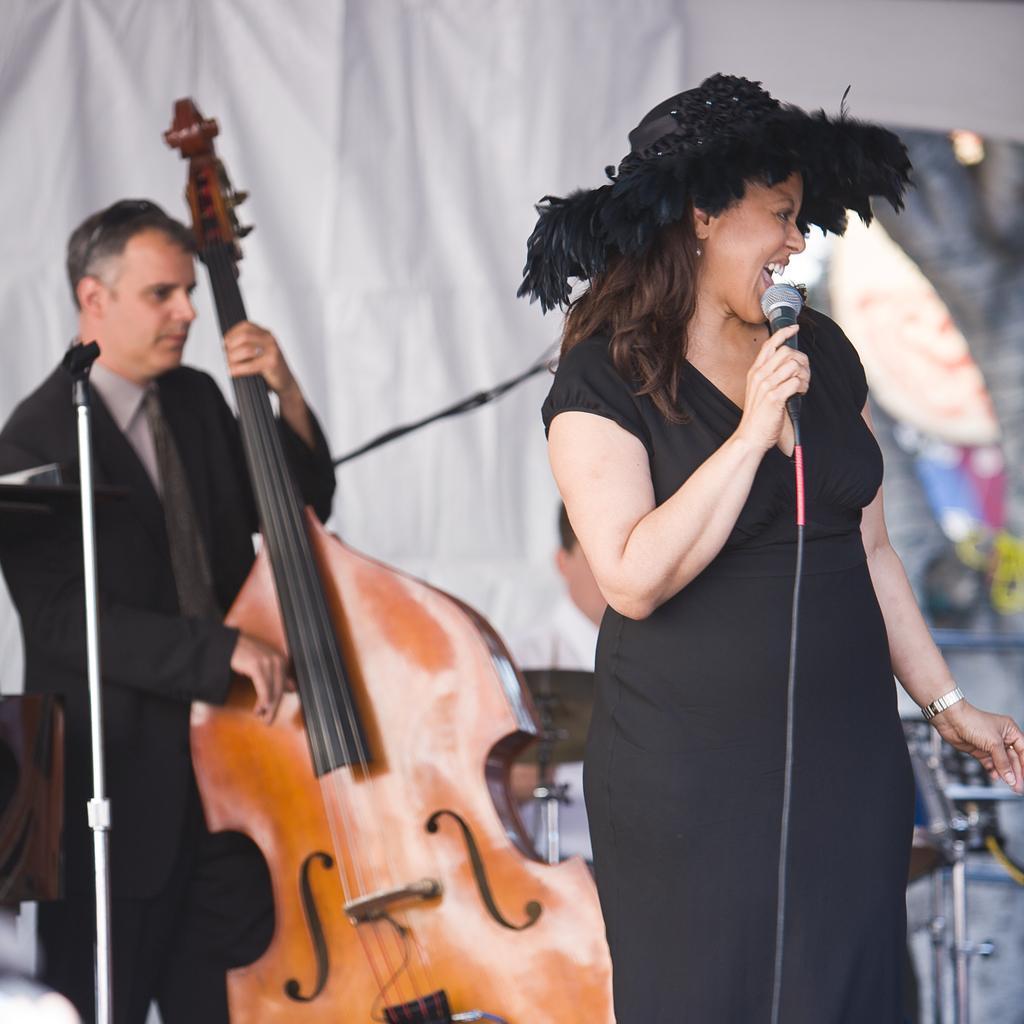In one or two sentences, can you explain what this image depicts? In the picture we can see a woman holding a microphone, she is wearing a hat and black dress, in the background we can see a man wearing a blazer with tie and holding a guitar near the micro phone, just beside him there is a white curtain, and some person sitting in front of the curtain. 